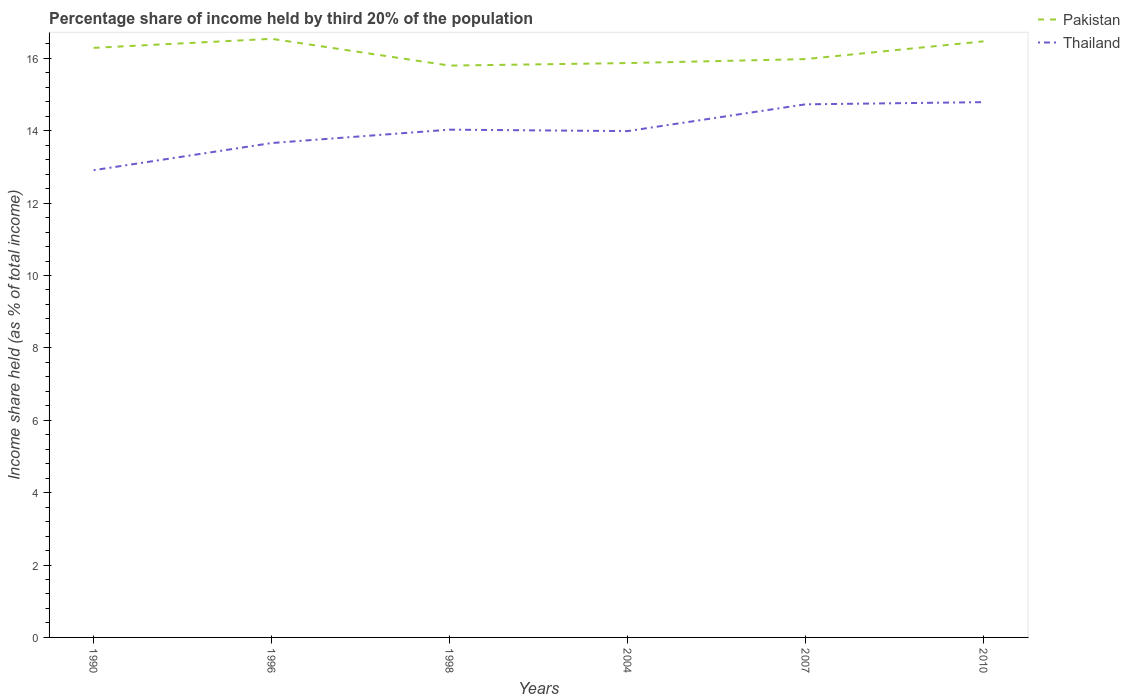Does the line corresponding to Pakistan intersect with the line corresponding to Thailand?
Make the answer very short. No. Is the number of lines equal to the number of legend labels?
Keep it short and to the point. Yes. Across all years, what is the maximum share of income held by third 20% of the population in Thailand?
Offer a terse response. 12.91. In which year was the share of income held by third 20% of the population in Thailand maximum?
Offer a very short reply. 1990. What is the total share of income held by third 20% of the population in Thailand in the graph?
Give a very brief answer. -0.33. What is the difference between the highest and the second highest share of income held by third 20% of the population in Thailand?
Make the answer very short. 1.88. What is the difference between the highest and the lowest share of income held by third 20% of the population in Pakistan?
Ensure brevity in your answer.  3. How many lines are there?
Provide a short and direct response. 2. What is the difference between two consecutive major ticks on the Y-axis?
Your answer should be compact. 2. Are the values on the major ticks of Y-axis written in scientific E-notation?
Your answer should be compact. No. Where does the legend appear in the graph?
Your response must be concise. Top right. How many legend labels are there?
Your response must be concise. 2. How are the legend labels stacked?
Provide a short and direct response. Vertical. What is the title of the graph?
Give a very brief answer. Percentage share of income held by third 20% of the population. What is the label or title of the X-axis?
Your answer should be compact. Years. What is the label or title of the Y-axis?
Ensure brevity in your answer.  Income share held (as % of total income). What is the Income share held (as % of total income) of Pakistan in 1990?
Keep it short and to the point. 16.29. What is the Income share held (as % of total income) in Thailand in 1990?
Make the answer very short. 12.91. What is the Income share held (as % of total income) of Pakistan in 1996?
Keep it short and to the point. 16.54. What is the Income share held (as % of total income) in Thailand in 1996?
Offer a very short reply. 13.66. What is the Income share held (as % of total income) in Pakistan in 1998?
Ensure brevity in your answer.  15.8. What is the Income share held (as % of total income) in Thailand in 1998?
Offer a very short reply. 14.03. What is the Income share held (as % of total income) in Pakistan in 2004?
Offer a terse response. 15.87. What is the Income share held (as % of total income) of Thailand in 2004?
Keep it short and to the point. 13.99. What is the Income share held (as % of total income) in Pakistan in 2007?
Make the answer very short. 15.98. What is the Income share held (as % of total income) of Thailand in 2007?
Keep it short and to the point. 14.73. What is the Income share held (as % of total income) in Pakistan in 2010?
Your answer should be very brief. 16.47. What is the Income share held (as % of total income) in Thailand in 2010?
Provide a short and direct response. 14.79. Across all years, what is the maximum Income share held (as % of total income) of Pakistan?
Offer a very short reply. 16.54. Across all years, what is the maximum Income share held (as % of total income) in Thailand?
Offer a terse response. 14.79. Across all years, what is the minimum Income share held (as % of total income) of Thailand?
Provide a short and direct response. 12.91. What is the total Income share held (as % of total income) in Pakistan in the graph?
Offer a terse response. 96.95. What is the total Income share held (as % of total income) of Thailand in the graph?
Make the answer very short. 84.11. What is the difference between the Income share held (as % of total income) of Pakistan in 1990 and that in 1996?
Provide a short and direct response. -0.25. What is the difference between the Income share held (as % of total income) of Thailand in 1990 and that in 1996?
Give a very brief answer. -0.75. What is the difference between the Income share held (as % of total income) of Pakistan in 1990 and that in 1998?
Give a very brief answer. 0.49. What is the difference between the Income share held (as % of total income) in Thailand in 1990 and that in 1998?
Your answer should be compact. -1.12. What is the difference between the Income share held (as % of total income) in Pakistan in 1990 and that in 2004?
Ensure brevity in your answer.  0.42. What is the difference between the Income share held (as % of total income) in Thailand in 1990 and that in 2004?
Give a very brief answer. -1.08. What is the difference between the Income share held (as % of total income) of Pakistan in 1990 and that in 2007?
Your answer should be compact. 0.31. What is the difference between the Income share held (as % of total income) of Thailand in 1990 and that in 2007?
Give a very brief answer. -1.82. What is the difference between the Income share held (as % of total income) of Pakistan in 1990 and that in 2010?
Give a very brief answer. -0.18. What is the difference between the Income share held (as % of total income) in Thailand in 1990 and that in 2010?
Offer a very short reply. -1.88. What is the difference between the Income share held (as % of total income) of Pakistan in 1996 and that in 1998?
Provide a short and direct response. 0.74. What is the difference between the Income share held (as % of total income) of Thailand in 1996 and that in 1998?
Offer a very short reply. -0.37. What is the difference between the Income share held (as % of total income) of Pakistan in 1996 and that in 2004?
Provide a succinct answer. 0.67. What is the difference between the Income share held (as % of total income) in Thailand in 1996 and that in 2004?
Offer a very short reply. -0.33. What is the difference between the Income share held (as % of total income) in Pakistan in 1996 and that in 2007?
Ensure brevity in your answer.  0.56. What is the difference between the Income share held (as % of total income) in Thailand in 1996 and that in 2007?
Offer a very short reply. -1.07. What is the difference between the Income share held (as % of total income) in Pakistan in 1996 and that in 2010?
Your answer should be very brief. 0.07. What is the difference between the Income share held (as % of total income) in Thailand in 1996 and that in 2010?
Your answer should be very brief. -1.13. What is the difference between the Income share held (as % of total income) of Pakistan in 1998 and that in 2004?
Offer a very short reply. -0.07. What is the difference between the Income share held (as % of total income) in Pakistan in 1998 and that in 2007?
Offer a terse response. -0.18. What is the difference between the Income share held (as % of total income) in Pakistan in 1998 and that in 2010?
Provide a short and direct response. -0.67. What is the difference between the Income share held (as % of total income) of Thailand in 1998 and that in 2010?
Ensure brevity in your answer.  -0.76. What is the difference between the Income share held (as % of total income) in Pakistan in 2004 and that in 2007?
Make the answer very short. -0.11. What is the difference between the Income share held (as % of total income) in Thailand in 2004 and that in 2007?
Give a very brief answer. -0.74. What is the difference between the Income share held (as % of total income) in Pakistan in 2004 and that in 2010?
Offer a very short reply. -0.6. What is the difference between the Income share held (as % of total income) in Pakistan in 2007 and that in 2010?
Your answer should be very brief. -0.49. What is the difference between the Income share held (as % of total income) of Thailand in 2007 and that in 2010?
Offer a very short reply. -0.06. What is the difference between the Income share held (as % of total income) of Pakistan in 1990 and the Income share held (as % of total income) of Thailand in 1996?
Provide a short and direct response. 2.63. What is the difference between the Income share held (as % of total income) in Pakistan in 1990 and the Income share held (as % of total income) in Thailand in 1998?
Provide a succinct answer. 2.26. What is the difference between the Income share held (as % of total income) of Pakistan in 1990 and the Income share held (as % of total income) of Thailand in 2004?
Provide a succinct answer. 2.3. What is the difference between the Income share held (as % of total income) of Pakistan in 1990 and the Income share held (as % of total income) of Thailand in 2007?
Make the answer very short. 1.56. What is the difference between the Income share held (as % of total income) in Pakistan in 1990 and the Income share held (as % of total income) in Thailand in 2010?
Offer a very short reply. 1.5. What is the difference between the Income share held (as % of total income) of Pakistan in 1996 and the Income share held (as % of total income) of Thailand in 1998?
Offer a very short reply. 2.51. What is the difference between the Income share held (as % of total income) in Pakistan in 1996 and the Income share held (as % of total income) in Thailand in 2004?
Your response must be concise. 2.55. What is the difference between the Income share held (as % of total income) in Pakistan in 1996 and the Income share held (as % of total income) in Thailand in 2007?
Provide a succinct answer. 1.81. What is the difference between the Income share held (as % of total income) of Pakistan in 1996 and the Income share held (as % of total income) of Thailand in 2010?
Provide a succinct answer. 1.75. What is the difference between the Income share held (as % of total income) in Pakistan in 1998 and the Income share held (as % of total income) in Thailand in 2004?
Your response must be concise. 1.81. What is the difference between the Income share held (as % of total income) of Pakistan in 1998 and the Income share held (as % of total income) of Thailand in 2007?
Offer a terse response. 1.07. What is the difference between the Income share held (as % of total income) of Pakistan in 2004 and the Income share held (as % of total income) of Thailand in 2007?
Your answer should be compact. 1.14. What is the difference between the Income share held (as % of total income) of Pakistan in 2007 and the Income share held (as % of total income) of Thailand in 2010?
Your response must be concise. 1.19. What is the average Income share held (as % of total income) in Pakistan per year?
Make the answer very short. 16.16. What is the average Income share held (as % of total income) of Thailand per year?
Your answer should be very brief. 14.02. In the year 1990, what is the difference between the Income share held (as % of total income) in Pakistan and Income share held (as % of total income) in Thailand?
Give a very brief answer. 3.38. In the year 1996, what is the difference between the Income share held (as % of total income) of Pakistan and Income share held (as % of total income) of Thailand?
Offer a very short reply. 2.88. In the year 1998, what is the difference between the Income share held (as % of total income) of Pakistan and Income share held (as % of total income) of Thailand?
Provide a short and direct response. 1.77. In the year 2004, what is the difference between the Income share held (as % of total income) in Pakistan and Income share held (as % of total income) in Thailand?
Your answer should be very brief. 1.88. In the year 2010, what is the difference between the Income share held (as % of total income) of Pakistan and Income share held (as % of total income) of Thailand?
Ensure brevity in your answer.  1.68. What is the ratio of the Income share held (as % of total income) in Pakistan in 1990 to that in 1996?
Your response must be concise. 0.98. What is the ratio of the Income share held (as % of total income) in Thailand in 1990 to that in 1996?
Ensure brevity in your answer.  0.95. What is the ratio of the Income share held (as % of total income) of Pakistan in 1990 to that in 1998?
Your response must be concise. 1.03. What is the ratio of the Income share held (as % of total income) of Thailand in 1990 to that in 1998?
Provide a short and direct response. 0.92. What is the ratio of the Income share held (as % of total income) of Pakistan in 1990 to that in 2004?
Provide a short and direct response. 1.03. What is the ratio of the Income share held (as % of total income) of Thailand in 1990 to that in 2004?
Offer a terse response. 0.92. What is the ratio of the Income share held (as % of total income) of Pakistan in 1990 to that in 2007?
Ensure brevity in your answer.  1.02. What is the ratio of the Income share held (as % of total income) in Thailand in 1990 to that in 2007?
Ensure brevity in your answer.  0.88. What is the ratio of the Income share held (as % of total income) in Pakistan in 1990 to that in 2010?
Ensure brevity in your answer.  0.99. What is the ratio of the Income share held (as % of total income) in Thailand in 1990 to that in 2010?
Keep it short and to the point. 0.87. What is the ratio of the Income share held (as % of total income) of Pakistan in 1996 to that in 1998?
Keep it short and to the point. 1.05. What is the ratio of the Income share held (as % of total income) of Thailand in 1996 to that in 1998?
Offer a terse response. 0.97. What is the ratio of the Income share held (as % of total income) in Pakistan in 1996 to that in 2004?
Ensure brevity in your answer.  1.04. What is the ratio of the Income share held (as % of total income) in Thailand in 1996 to that in 2004?
Your answer should be very brief. 0.98. What is the ratio of the Income share held (as % of total income) in Pakistan in 1996 to that in 2007?
Make the answer very short. 1.03. What is the ratio of the Income share held (as % of total income) of Thailand in 1996 to that in 2007?
Give a very brief answer. 0.93. What is the ratio of the Income share held (as % of total income) of Thailand in 1996 to that in 2010?
Give a very brief answer. 0.92. What is the ratio of the Income share held (as % of total income) of Pakistan in 1998 to that in 2004?
Your answer should be compact. 1. What is the ratio of the Income share held (as % of total income) in Thailand in 1998 to that in 2004?
Ensure brevity in your answer.  1. What is the ratio of the Income share held (as % of total income) in Pakistan in 1998 to that in 2007?
Provide a succinct answer. 0.99. What is the ratio of the Income share held (as % of total income) in Thailand in 1998 to that in 2007?
Your answer should be very brief. 0.95. What is the ratio of the Income share held (as % of total income) of Pakistan in 1998 to that in 2010?
Ensure brevity in your answer.  0.96. What is the ratio of the Income share held (as % of total income) in Thailand in 1998 to that in 2010?
Ensure brevity in your answer.  0.95. What is the ratio of the Income share held (as % of total income) of Thailand in 2004 to that in 2007?
Offer a terse response. 0.95. What is the ratio of the Income share held (as % of total income) in Pakistan in 2004 to that in 2010?
Offer a terse response. 0.96. What is the ratio of the Income share held (as % of total income) in Thailand in 2004 to that in 2010?
Make the answer very short. 0.95. What is the ratio of the Income share held (as % of total income) in Pakistan in 2007 to that in 2010?
Your answer should be very brief. 0.97. What is the ratio of the Income share held (as % of total income) in Thailand in 2007 to that in 2010?
Offer a very short reply. 1. What is the difference between the highest and the second highest Income share held (as % of total income) in Pakistan?
Ensure brevity in your answer.  0.07. What is the difference between the highest and the lowest Income share held (as % of total income) in Pakistan?
Provide a succinct answer. 0.74. What is the difference between the highest and the lowest Income share held (as % of total income) in Thailand?
Provide a succinct answer. 1.88. 